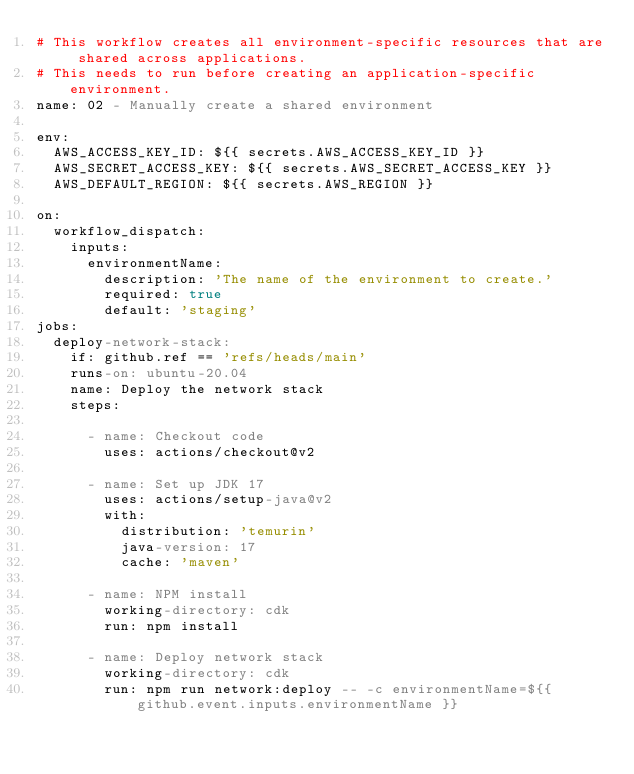<code> <loc_0><loc_0><loc_500><loc_500><_YAML_># This workflow creates all environment-specific resources that are shared across applications.
# This needs to run before creating an application-specific environment.
name: 02 - Manually create a shared environment

env:
  AWS_ACCESS_KEY_ID: ${{ secrets.AWS_ACCESS_KEY_ID }}
  AWS_SECRET_ACCESS_KEY: ${{ secrets.AWS_SECRET_ACCESS_KEY }}
  AWS_DEFAULT_REGION: ${{ secrets.AWS_REGION }}

on:
  workflow_dispatch:
    inputs:
      environmentName:
        description: 'The name of the environment to create.'
        required: true
        default: 'staging'
jobs:
  deploy-network-stack:
    if: github.ref == 'refs/heads/main'
    runs-on: ubuntu-20.04
    name: Deploy the network stack
    steps:

      - name: Checkout code
        uses: actions/checkout@v2

      - name: Set up JDK 17
        uses: actions/setup-java@v2
        with:
          distribution: 'temurin'
          java-version: 17
          cache: 'maven'

      - name: NPM install
        working-directory: cdk
        run: npm install

      - name: Deploy network stack
        working-directory: cdk
        run: npm run network:deploy -- -c environmentName=${{ github.event.inputs.environmentName }}
</code> 